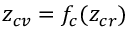<formula> <loc_0><loc_0><loc_500><loc_500>z _ { c v } = f _ { c } ( z _ { c r } )</formula> 